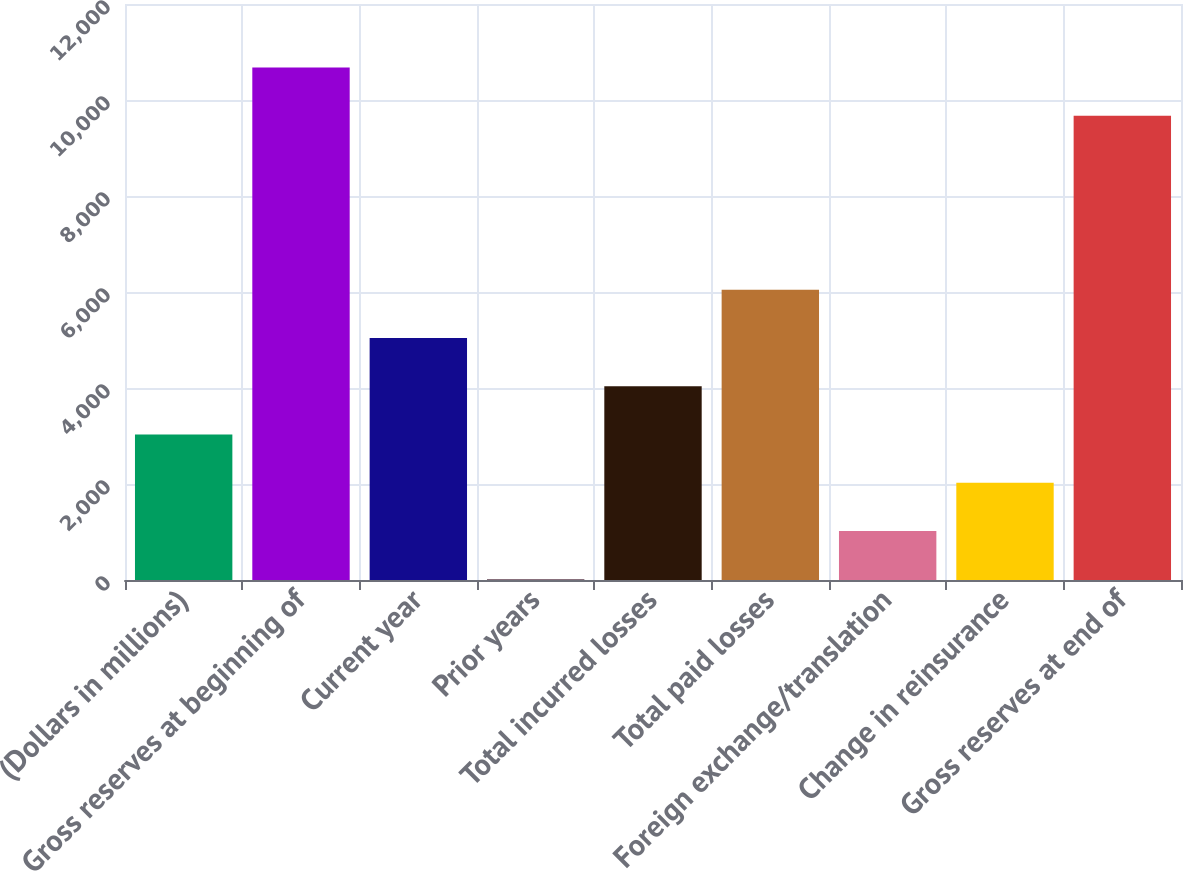<chart> <loc_0><loc_0><loc_500><loc_500><bar_chart><fcel>(Dollars in millions)<fcel>Gross reserves at beginning of<fcel>Current year<fcel>Prior years<fcel>Total incurred losses<fcel>Total paid losses<fcel>Foreign exchange/translation<fcel>Change in reinsurance<fcel>Gross reserves at end of<nl><fcel>3033.47<fcel>10678.3<fcel>5043.65<fcel>18.2<fcel>4038.56<fcel>6048.74<fcel>1023.29<fcel>2028.38<fcel>9673.2<nl></chart> 